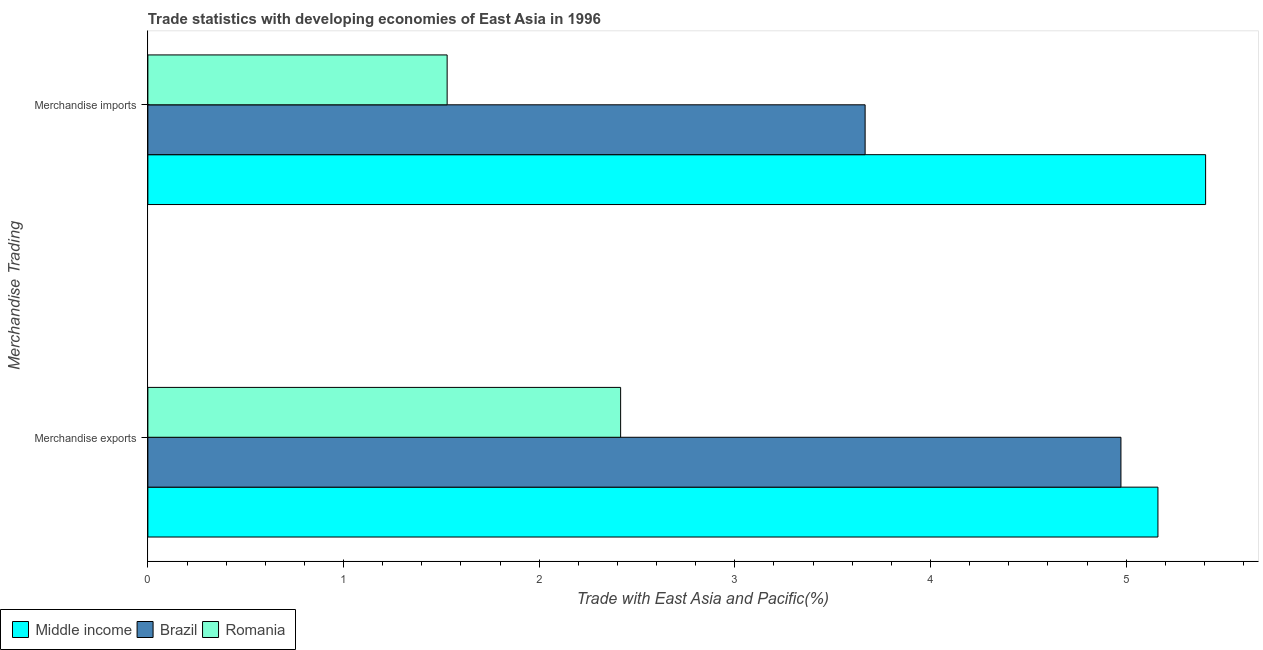What is the merchandise imports in Brazil?
Your answer should be compact. 3.67. Across all countries, what is the maximum merchandise exports?
Provide a short and direct response. 5.16. Across all countries, what is the minimum merchandise imports?
Offer a very short reply. 1.53. In which country was the merchandise exports minimum?
Give a very brief answer. Romania. What is the total merchandise imports in the graph?
Ensure brevity in your answer.  10.6. What is the difference between the merchandise exports in Romania and that in Middle income?
Make the answer very short. -2.75. What is the difference between the merchandise imports in Middle income and the merchandise exports in Romania?
Your response must be concise. 2.99. What is the average merchandise imports per country?
Provide a succinct answer. 3.53. What is the difference between the merchandise imports and merchandise exports in Brazil?
Provide a succinct answer. -1.31. In how many countries, is the merchandise exports greater than 4 %?
Provide a succinct answer. 2. What is the ratio of the merchandise exports in Romania to that in Brazil?
Your answer should be compact. 0.49. Is the merchandise imports in Middle income less than that in Romania?
Keep it short and to the point. No. What does the 3rd bar from the top in Merchandise exports represents?
Your answer should be compact. Middle income. What does the 2nd bar from the bottom in Merchandise imports represents?
Provide a succinct answer. Brazil. How many bars are there?
Offer a terse response. 6. Are all the bars in the graph horizontal?
Offer a very short reply. Yes. How many countries are there in the graph?
Give a very brief answer. 3. What is the difference between two consecutive major ticks on the X-axis?
Make the answer very short. 1. Are the values on the major ticks of X-axis written in scientific E-notation?
Provide a short and direct response. No. Does the graph contain any zero values?
Offer a terse response. No. Where does the legend appear in the graph?
Provide a succinct answer. Bottom left. What is the title of the graph?
Offer a terse response. Trade statistics with developing economies of East Asia in 1996. Does "Monaco" appear as one of the legend labels in the graph?
Your answer should be very brief. No. What is the label or title of the X-axis?
Keep it short and to the point. Trade with East Asia and Pacific(%). What is the label or title of the Y-axis?
Give a very brief answer. Merchandise Trading. What is the Trade with East Asia and Pacific(%) in Middle income in Merchandise exports?
Your answer should be compact. 5.16. What is the Trade with East Asia and Pacific(%) of Brazil in Merchandise exports?
Keep it short and to the point. 4.97. What is the Trade with East Asia and Pacific(%) of Romania in Merchandise exports?
Your response must be concise. 2.42. What is the Trade with East Asia and Pacific(%) of Middle income in Merchandise imports?
Offer a very short reply. 5.41. What is the Trade with East Asia and Pacific(%) of Brazil in Merchandise imports?
Your answer should be very brief. 3.67. What is the Trade with East Asia and Pacific(%) of Romania in Merchandise imports?
Give a very brief answer. 1.53. Across all Merchandise Trading, what is the maximum Trade with East Asia and Pacific(%) of Middle income?
Provide a succinct answer. 5.41. Across all Merchandise Trading, what is the maximum Trade with East Asia and Pacific(%) of Brazil?
Make the answer very short. 4.97. Across all Merchandise Trading, what is the maximum Trade with East Asia and Pacific(%) in Romania?
Keep it short and to the point. 2.42. Across all Merchandise Trading, what is the minimum Trade with East Asia and Pacific(%) in Middle income?
Provide a succinct answer. 5.16. Across all Merchandise Trading, what is the minimum Trade with East Asia and Pacific(%) of Brazil?
Make the answer very short. 3.67. Across all Merchandise Trading, what is the minimum Trade with East Asia and Pacific(%) in Romania?
Your answer should be compact. 1.53. What is the total Trade with East Asia and Pacific(%) in Middle income in the graph?
Your answer should be very brief. 10.57. What is the total Trade with East Asia and Pacific(%) in Brazil in the graph?
Offer a terse response. 8.64. What is the total Trade with East Asia and Pacific(%) in Romania in the graph?
Provide a succinct answer. 3.95. What is the difference between the Trade with East Asia and Pacific(%) of Middle income in Merchandise exports and that in Merchandise imports?
Keep it short and to the point. -0.24. What is the difference between the Trade with East Asia and Pacific(%) of Brazil in Merchandise exports and that in Merchandise imports?
Make the answer very short. 1.31. What is the difference between the Trade with East Asia and Pacific(%) in Romania in Merchandise exports and that in Merchandise imports?
Keep it short and to the point. 0.89. What is the difference between the Trade with East Asia and Pacific(%) of Middle income in Merchandise exports and the Trade with East Asia and Pacific(%) of Brazil in Merchandise imports?
Ensure brevity in your answer.  1.5. What is the difference between the Trade with East Asia and Pacific(%) in Middle income in Merchandise exports and the Trade with East Asia and Pacific(%) in Romania in Merchandise imports?
Keep it short and to the point. 3.63. What is the difference between the Trade with East Asia and Pacific(%) of Brazil in Merchandise exports and the Trade with East Asia and Pacific(%) of Romania in Merchandise imports?
Provide a short and direct response. 3.44. What is the average Trade with East Asia and Pacific(%) in Middle income per Merchandise Trading?
Your answer should be compact. 5.28. What is the average Trade with East Asia and Pacific(%) of Brazil per Merchandise Trading?
Your answer should be very brief. 4.32. What is the average Trade with East Asia and Pacific(%) in Romania per Merchandise Trading?
Give a very brief answer. 1.97. What is the difference between the Trade with East Asia and Pacific(%) in Middle income and Trade with East Asia and Pacific(%) in Brazil in Merchandise exports?
Provide a succinct answer. 0.19. What is the difference between the Trade with East Asia and Pacific(%) in Middle income and Trade with East Asia and Pacific(%) in Romania in Merchandise exports?
Your response must be concise. 2.75. What is the difference between the Trade with East Asia and Pacific(%) in Brazil and Trade with East Asia and Pacific(%) in Romania in Merchandise exports?
Offer a very short reply. 2.56. What is the difference between the Trade with East Asia and Pacific(%) of Middle income and Trade with East Asia and Pacific(%) of Brazil in Merchandise imports?
Offer a very short reply. 1.74. What is the difference between the Trade with East Asia and Pacific(%) of Middle income and Trade with East Asia and Pacific(%) of Romania in Merchandise imports?
Your answer should be compact. 3.88. What is the difference between the Trade with East Asia and Pacific(%) of Brazil and Trade with East Asia and Pacific(%) of Romania in Merchandise imports?
Your response must be concise. 2.14. What is the ratio of the Trade with East Asia and Pacific(%) in Middle income in Merchandise exports to that in Merchandise imports?
Your answer should be compact. 0.95. What is the ratio of the Trade with East Asia and Pacific(%) of Brazil in Merchandise exports to that in Merchandise imports?
Give a very brief answer. 1.36. What is the ratio of the Trade with East Asia and Pacific(%) in Romania in Merchandise exports to that in Merchandise imports?
Your answer should be very brief. 1.58. What is the difference between the highest and the second highest Trade with East Asia and Pacific(%) in Middle income?
Ensure brevity in your answer.  0.24. What is the difference between the highest and the second highest Trade with East Asia and Pacific(%) in Brazil?
Offer a very short reply. 1.31. What is the difference between the highest and the second highest Trade with East Asia and Pacific(%) of Romania?
Your answer should be very brief. 0.89. What is the difference between the highest and the lowest Trade with East Asia and Pacific(%) of Middle income?
Give a very brief answer. 0.24. What is the difference between the highest and the lowest Trade with East Asia and Pacific(%) in Brazil?
Offer a very short reply. 1.31. What is the difference between the highest and the lowest Trade with East Asia and Pacific(%) of Romania?
Make the answer very short. 0.89. 